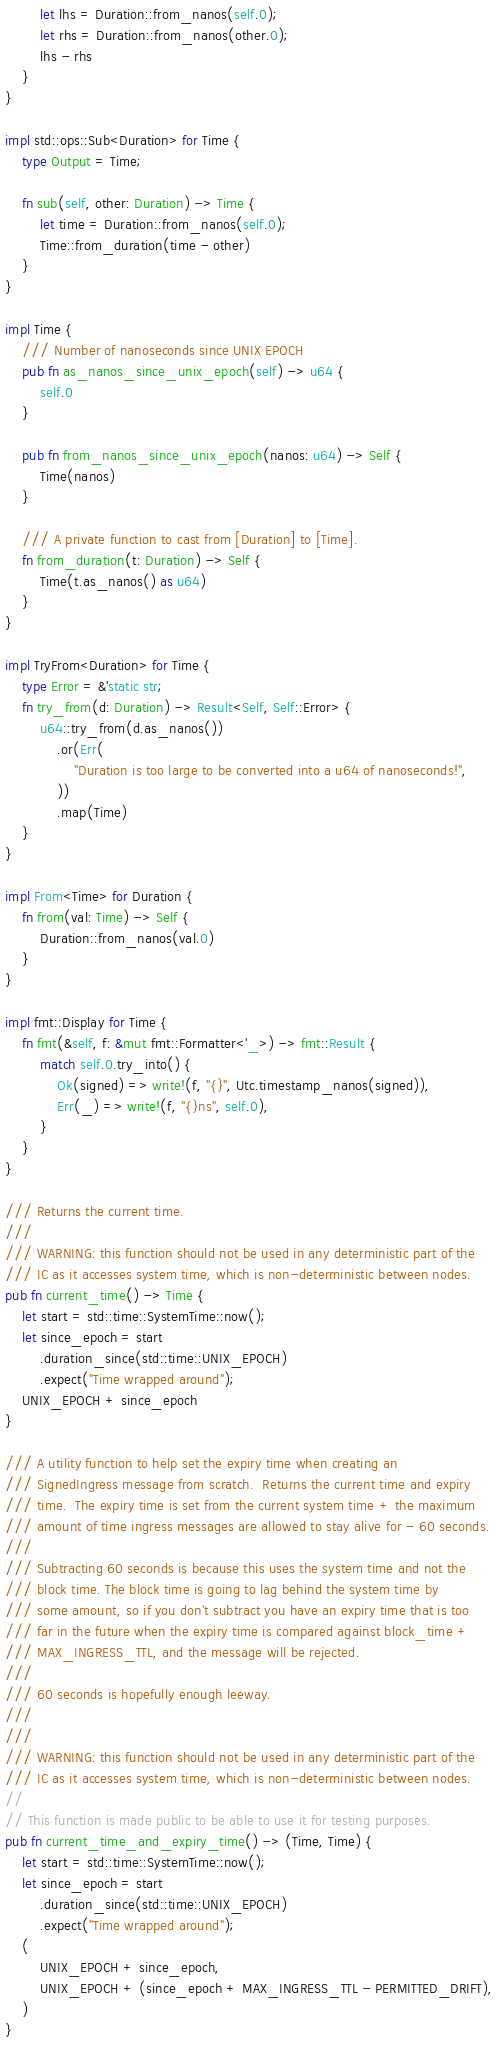Convert code to text. <code><loc_0><loc_0><loc_500><loc_500><_Rust_>        let lhs = Duration::from_nanos(self.0);
        let rhs = Duration::from_nanos(other.0);
        lhs - rhs
    }
}

impl std::ops::Sub<Duration> for Time {
    type Output = Time;

    fn sub(self, other: Duration) -> Time {
        let time = Duration::from_nanos(self.0);
        Time::from_duration(time - other)
    }
}

impl Time {
    /// Number of nanoseconds since UNIX EPOCH
    pub fn as_nanos_since_unix_epoch(self) -> u64 {
        self.0
    }

    pub fn from_nanos_since_unix_epoch(nanos: u64) -> Self {
        Time(nanos)
    }

    /// A private function to cast from [Duration] to [Time].
    fn from_duration(t: Duration) -> Self {
        Time(t.as_nanos() as u64)
    }
}

impl TryFrom<Duration> for Time {
    type Error = &'static str;
    fn try_from(d: Duration) -> Result<Self, Self::Error> {
        u64::try_from(d.as_nanos())
            .or(Err(
                "Duration is too large to be converted into a u64 of nanoseconds!",
            ))
            .map(Time)
    }
}

impl From<Time> for Duration {
    fn from(val: Time) -> Self {
        Duration::from_nanos(val.0)
    }
}

impl fmt::Display for Time {
    fn fmt(&self, f: &mut fmt::Formatter<'_>) -> fmt::Result {
        match self.0.try_into() {
            Ok(signed) => write!(f, "{}", Utc.timestamp_nanos(signed)),
            Err(_) => write!(f, "{}ns", self.0),
        }
    }
}

/// Returns the current time.
///
/// WARNING: this function should not be used in any deterministic part of the
/// IC as it accesses system time, which is non-deterministic between nodes.
pub fn current_time() -> Time {
    let start = std::time::SystemTime::now();
    let since_epoch = start
        .duration_since(std::time::UNIX_EPOCH)
        .expect("Time wrapped around");
    UNIX_EPOCH + since_epoch
}

/// A utility function to help set the expiry time when creating an
/// SignedIngress message from scratch.  Returns the current time and expiry
/// time.  The expiry time is set from the current system time + the maximum
/// amount of time ingress messages are allowed to stay alive for - 60 seconds.
///
/// Subtracting 60 seconds is because this uses the system time and not the
/// block time. The block time is going to lag behind the system time by
/// some amount, so if you don't subtract you have an expiry time that is too
/// far in the future when the expiry time is compared against block_time +
/// MAX_INGRESS_TTL, and the message will be rejected.
///
/// 60 seconds is hopefully enough leeway.
///
///
/// WARNING: this function should not be used in any deterministic part of the
/// IC as it accesses system time, which is non-deterministic between nodes.
//
// This function is made public to be able to use it for testing purposes.
pub fn current_time_and_expiry_time() -> (Time, Time) {
    let start = std::time::SystemTime::now();
    let since_epoch = start
        .duration_since(std::time::UNIX_EPOCH)
        .expect("Time wrapped around");
    (
        UNIX_EPOCH + since_epoch,
        UNIX_EPOCH + (since_epoch + MAX_INGRESS_TTL - PERMITTED_DRIFT),
    )
}
</code> 